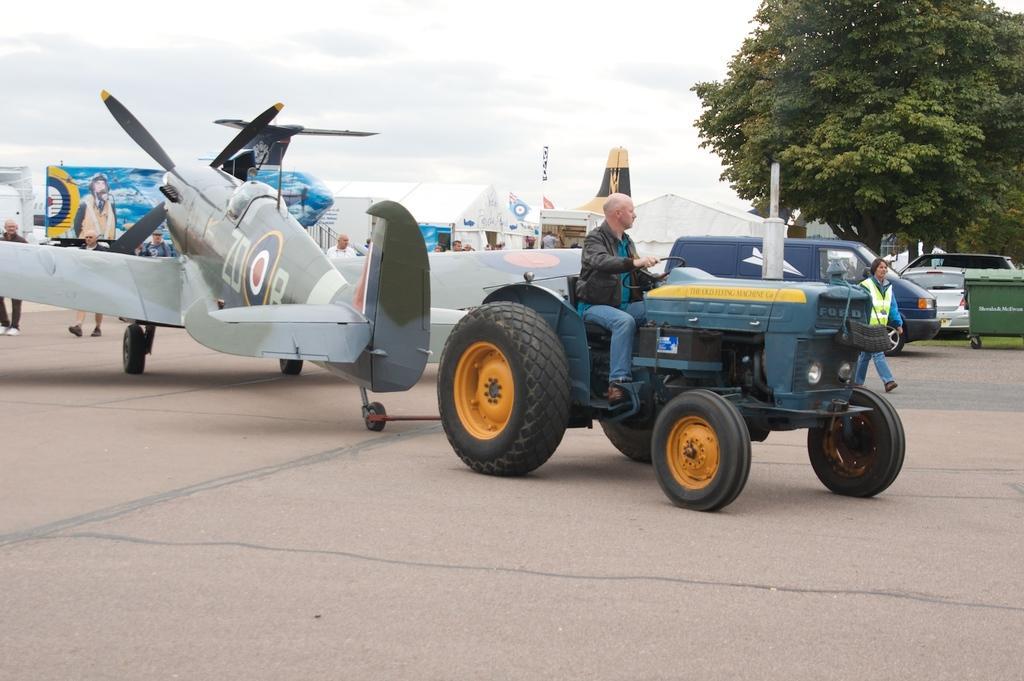Please provide a concise description of this image. In this image I can see a person sitting in the vehicle and the person is wearing brown jacket, blue pant. Background I can see few other vehicles. In front I can see an aircraft which is in white color, background I can see trees in green color and the sky is in white color. 